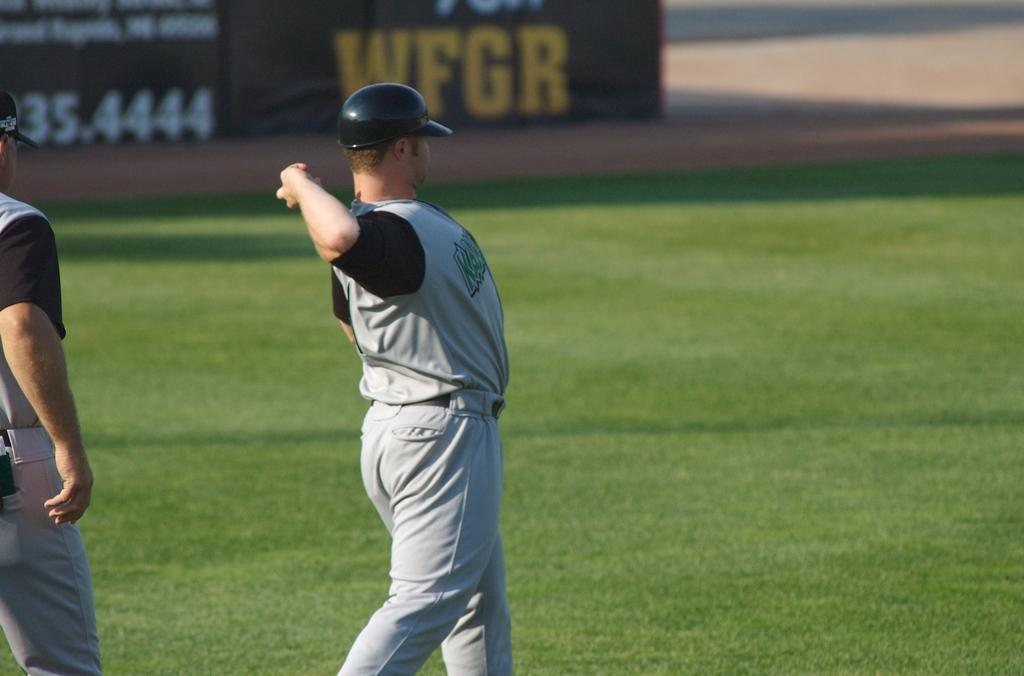What is the surface that the persons are standing on in the image? The persons are standing on the grass in the image. What can be seen in the background of the image? The ground is visible in the background of the image. What type of footwear are the persons wearing to protect their toes from the sleet in the image? There is no mention of sleet or footwear in the image, so it cannot be determined what type of footwear the persons might be wearing. 